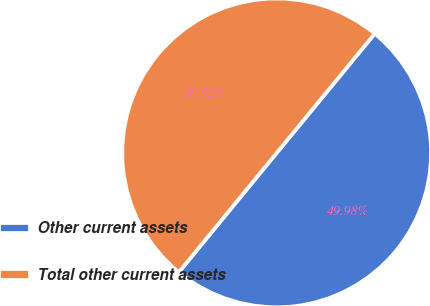Convert chart. <chart><loc_0><loc_0><loc_500><loc_500><pie_chart><fcel>Other current assets<fcel>Total other current assets<nl><fcel>49.98%<fcel>50.02%<nl></chart> 